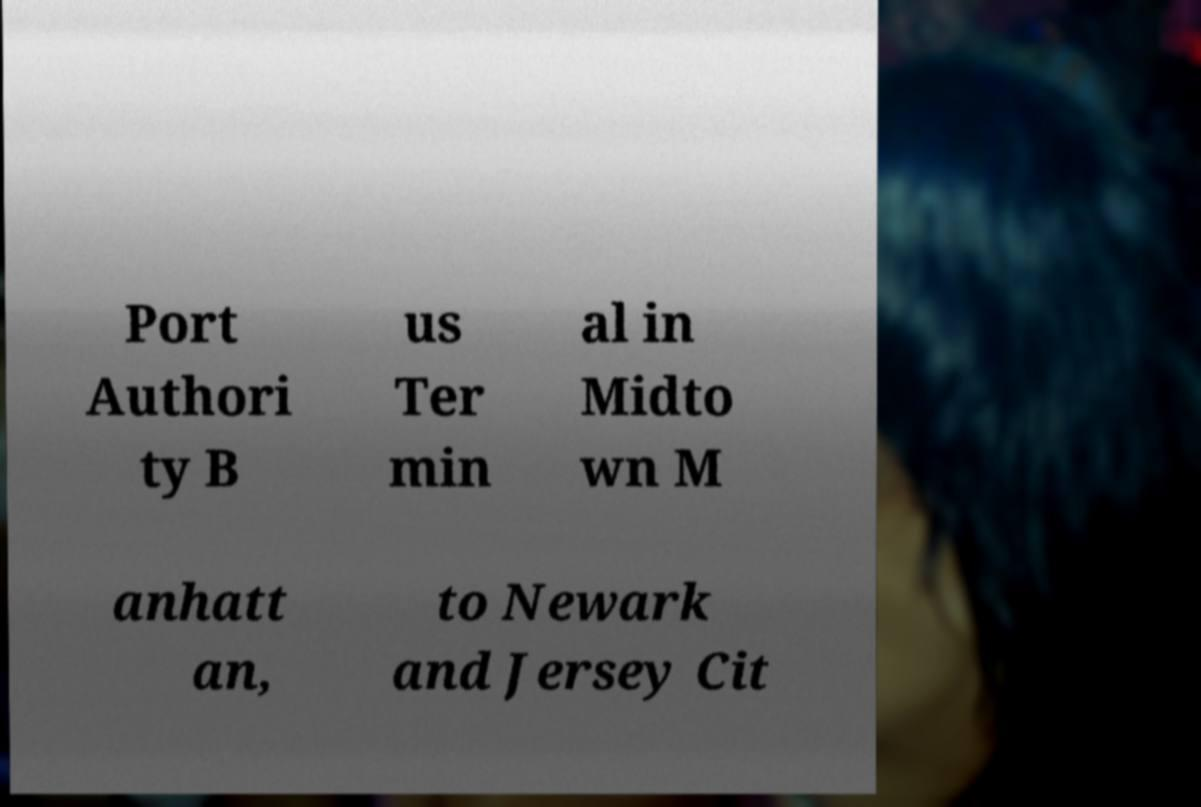Can you accurately transcribe the text from the provided image for me? Port Authori ty B us Ter min al in Midto wn M anhatt an, to Newark and Jersey Cit 